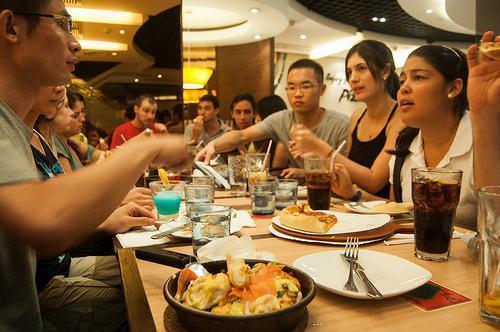How many plates have no food?
Give a very brief answer. 1. 